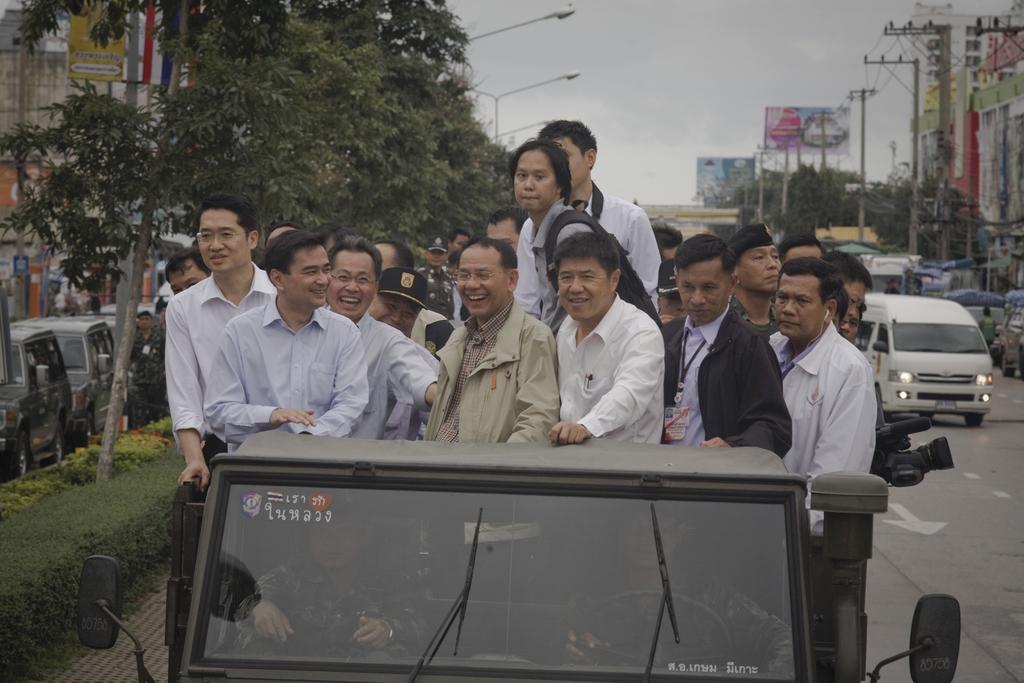Could you give a brief overview of what you see in this image? As we can see in the image there are group of standing people on vehicles. There are trees, buildings, street lamps, current poles, banners, plants and vehicles. 